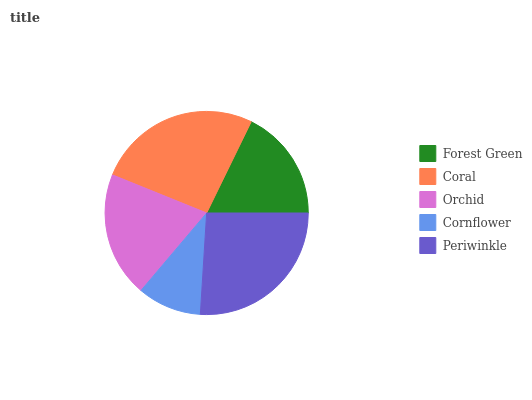Is Cornflower the minimum?
Answer yes or no. Yes. Is Coral the maximum?
Answer yes or no. Yes. Is Orchid the minimum?
Answer yes or no. No. Is Orchid the maximum?
Answer yes or no. No. Is Coral greater than Orchid?
Answer yes or no. Yes. Is Orchid less than Coral?
Answer yes or no. Yes. Is Orchid greater than Coral?
Answer yes or no. No. Is Coral less than Orchid?
Answer yes or no. No. Is Orchid the high median?
Answer yes or no. Yes. Is Orchid the low median?
Answer yes or no. Yes. Is Periwinkle the high median?
Answer yes or no. No. Is Cornflower the low median?
Answer yes or no. No. 